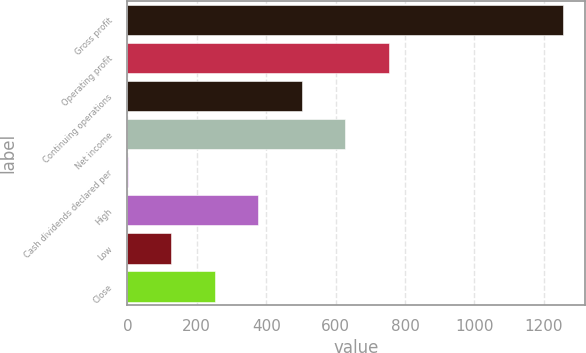Convert chart. <chart><loc_0><loc_0><loc_500><loc_500><bar_chart><fcel>Gross profit<fcel>Operating profit<fcel>Continuing operations<fcel>Net income<fcel>Cash dividends declared per<fcel>High<fcel>Low<fcel>Close<nl><fcel>1255.7<fcel>753.58<fcel>502.52<fcel>628.05<fcel>0.4<fcel>376.99<fcel>125.93<fcel>251.46<nl></chart> 